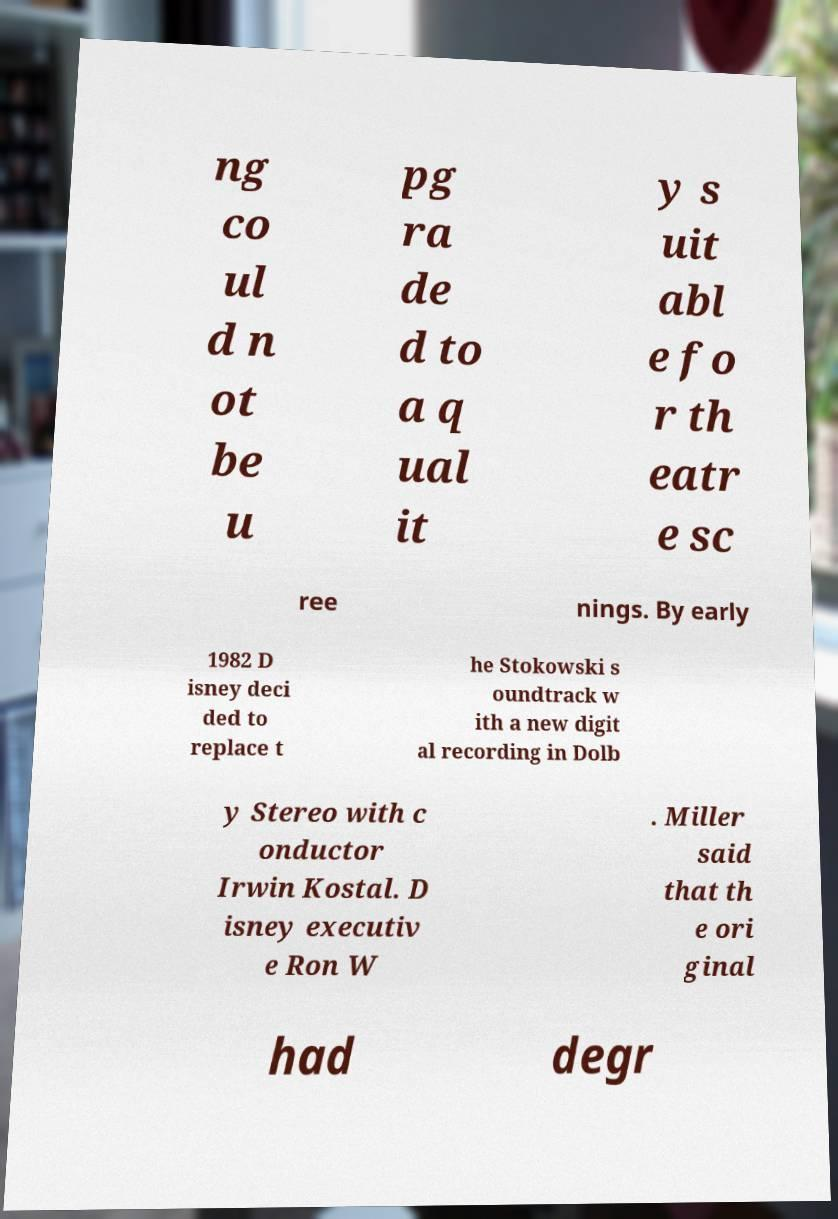Can you accurately transcribe the text from the provided image for me? ng co ul d n ot be u pg ra de d to a q ual it y s uit abl e fo r th eatr e sc ree nings. By early 1982 D isney deci ded to replace t he Stokowski s oundtrack w ith a new digit al recording in Dolb y Stereo with c onductor Irwin Kostal. D isney executiv e Ron W . Miller said that th e ori ginal had degr 